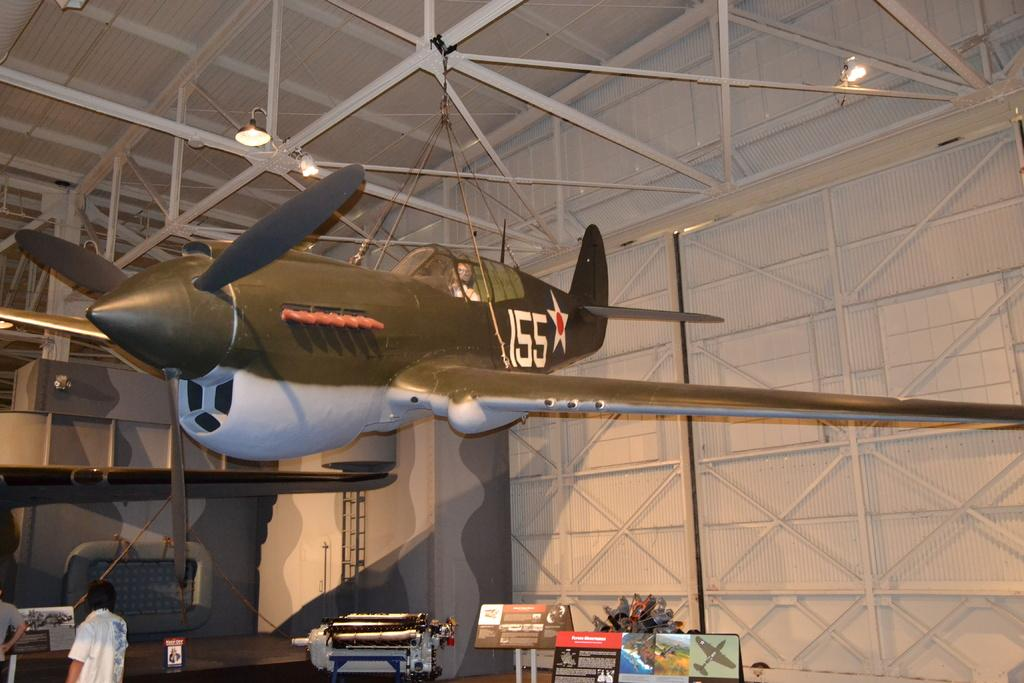<image>
Create a compact narrative representing the image presented. A world war II plane (155 on fuselage) which is suspended from a ceiling 